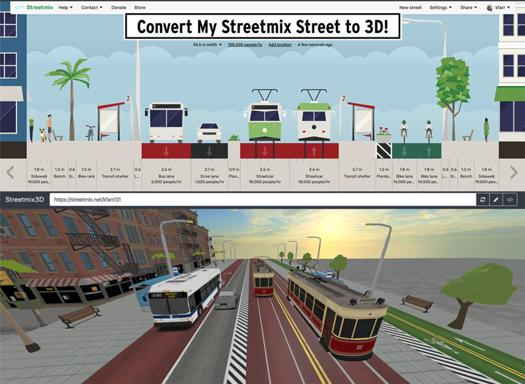Could you explain the process of converting a Streetmix design into a 3D model? The conversion process involves rendering the 2D elements of the street design into 3D models using specialized software algorithms. This transition allows viewing the design from various angles and simulates a more realistic urban environment. 